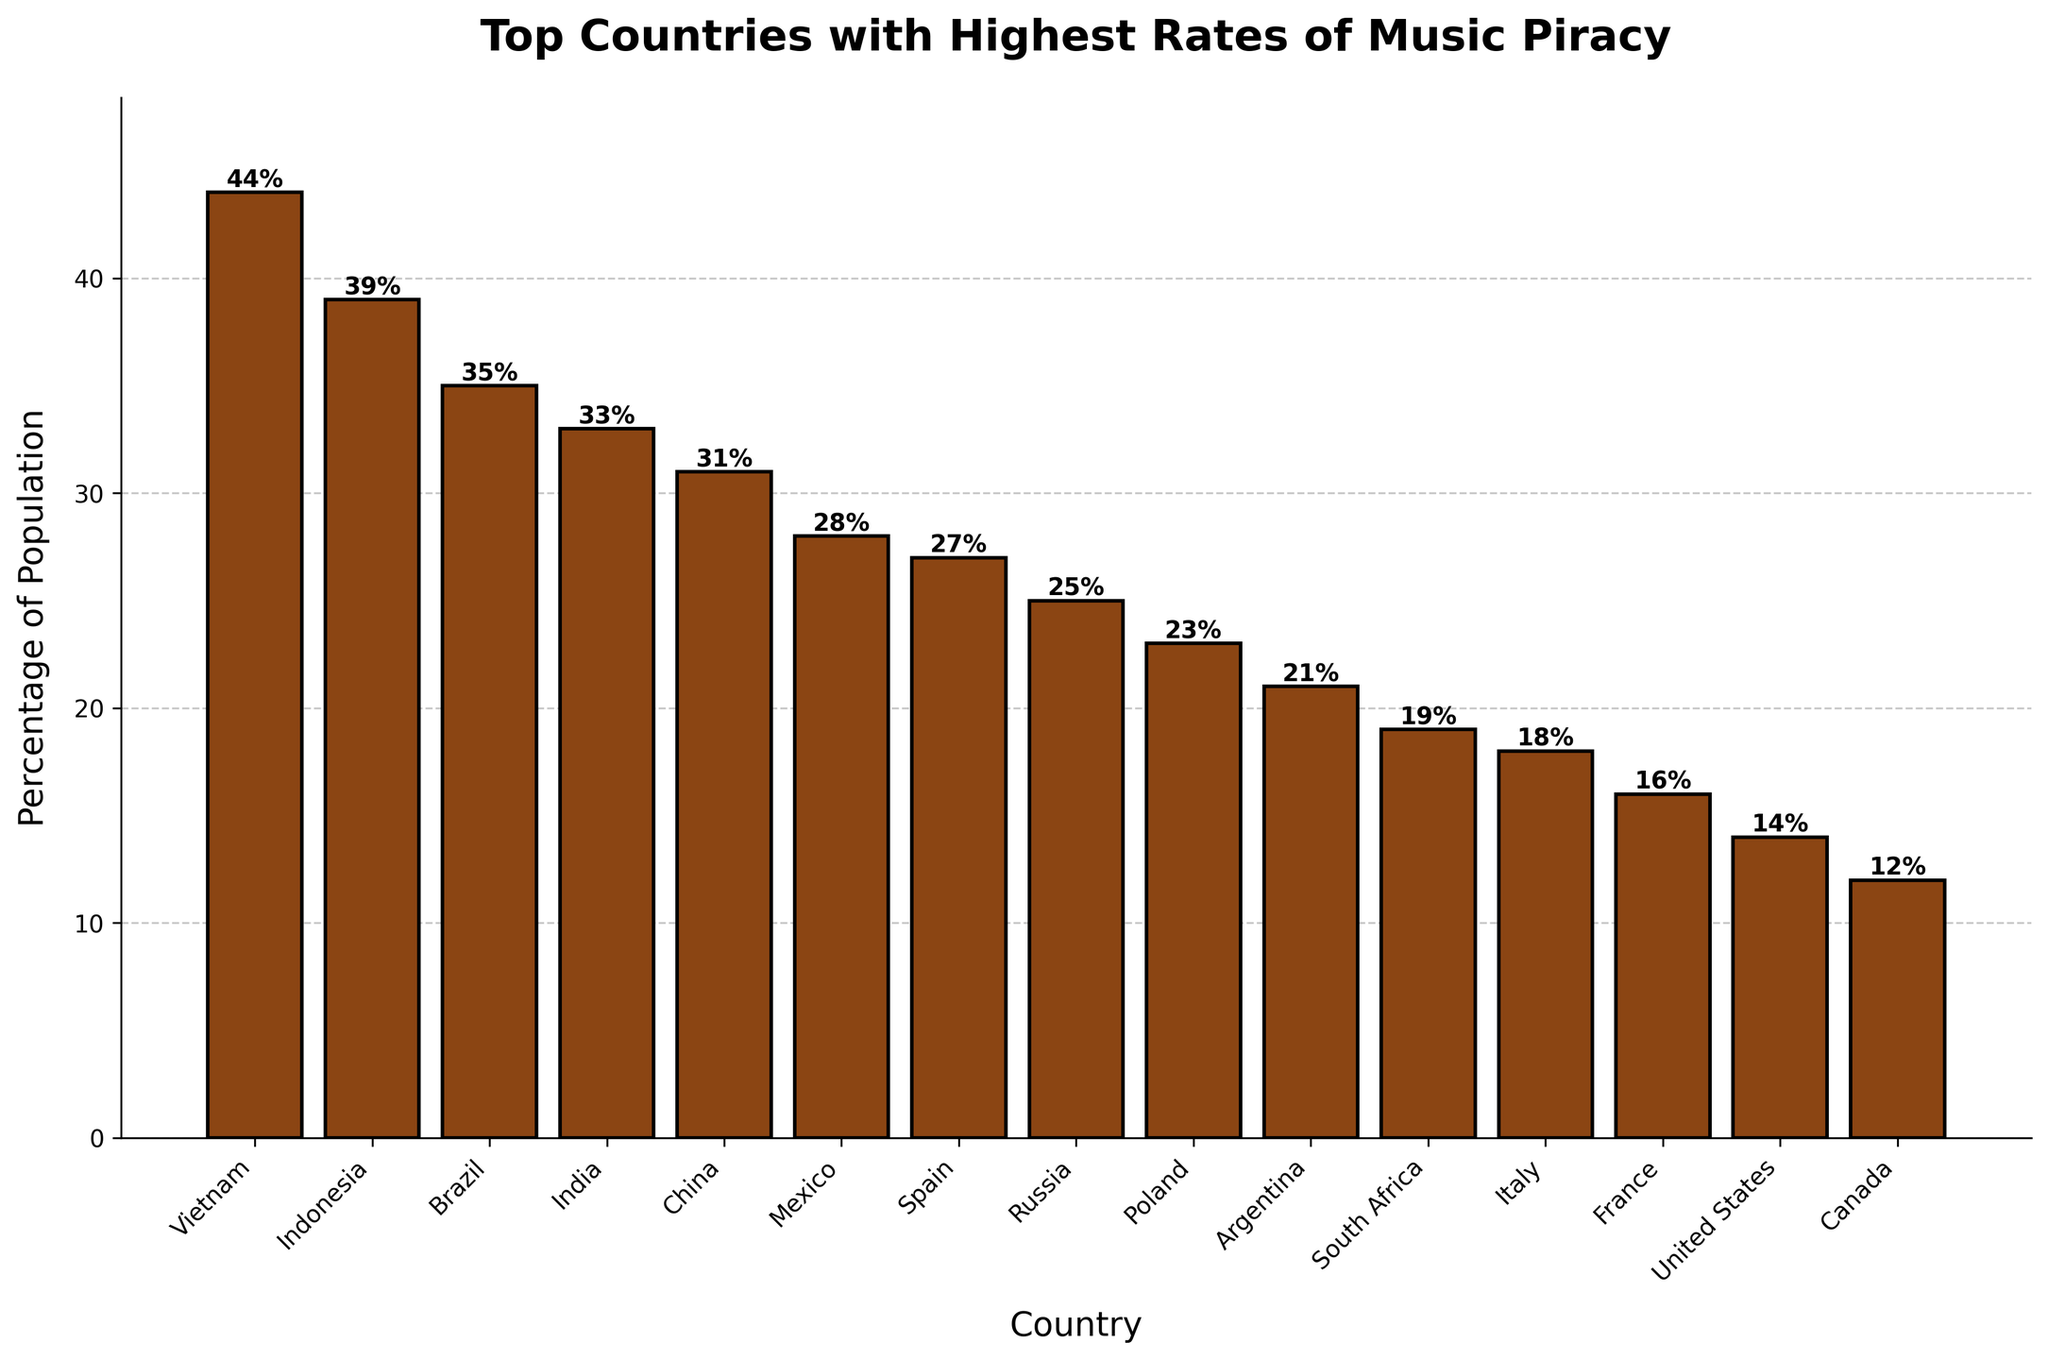Which country has the highest rate of music piracy? The country with the highest bar represents the country with the highest rate of music piracy. In this case, Vietnam has the highest bar at 44%.
Answer: Vietnam Which country has the lowest rate of music piracy? The country with the smallest bar represents the country with the lowest rate of music piracy. In this case, Canada has the smallest bar at 12%.
Answer: Canada What is the percentage difference between Vietnam and Indonesia? Subtract the percentage of Indonesia (39%) from Vietnam (44%). The difference is 44% - 39% = 5%.
Answer: 5% What is the average percentage of music piracy for the top 5 countries? Sum the percentages of the top 5 countries (Vietnam: 44%, Indonesia: 39%, Brazil: 35%, India: 33%, China: 31%) and divide by 5. The sum is 44 + 39 + 35 + 33 + 31 = 182, so the average is 182 / 5 = 36.4%.
Answer: 36.4% Which countries have a music piracy rate greater than 30%? Look at the countries whose bars extend above the 30% mark. Those countries are Vietnam (44%), Indonesia (39%), Brazil (35%), India (33%), and China (31%).
Answer: Vietnam, Indonesia, Brazil, India, China What are the combined percentages of music piracy for Russia and Poland? Add the percentages of Russia (25%) and Poland (23%). The combined percentage is 25 + 23 = 48%.
Answer: 48% Which countries have a piracy rate less than 20%? Look at the countries whose bars do not reach the 20% mark. Those countries are South Africa (19%), Italy (18%), France (16%), United States (14%), and Canada (12%).
Answer: South Africa, Italy, France, United States, Canada Is the music piracy rate in Brazil higher or lower than in Mexico? Compare the heights of the bars for Brazil and Mexico. Brazil has a 35% piracy rate, while Mexico has 28%. Brazil's rate is higher.
Answer: Higher How many countries have a music piracy rate between 20% and 30%? Count the countries whose bars are between the 20% and 30% marks. Those countries are Mexico (28%), Spain (27%), Russia (25%), and Poland (23%).
Answer: 4 What is the median piracy rate among the listed countries? Arrange the percentages in ascending order and find the middle value. Percentages are 12, 14, 16, 18, 19, 21, 23, 25, 27, 28, 31, 33, 35, 39, 44. The median value (middle one) is the 8th value: 25%.
Answer: 25% 